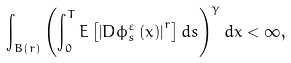Convert formula to latex. <formula><loc_0><loc_0><loc_500><loc_500>\int _ { B ( r ) } \left ( \int _ { 0 } ^ { T } E \left [ \left | D { \phi } ^ { \varepsilon } _ { s } \left ( x \right ) \right | ^ { r } \right ] d s \right ) ^ { \gamma } d x < \infty ,</formula> 